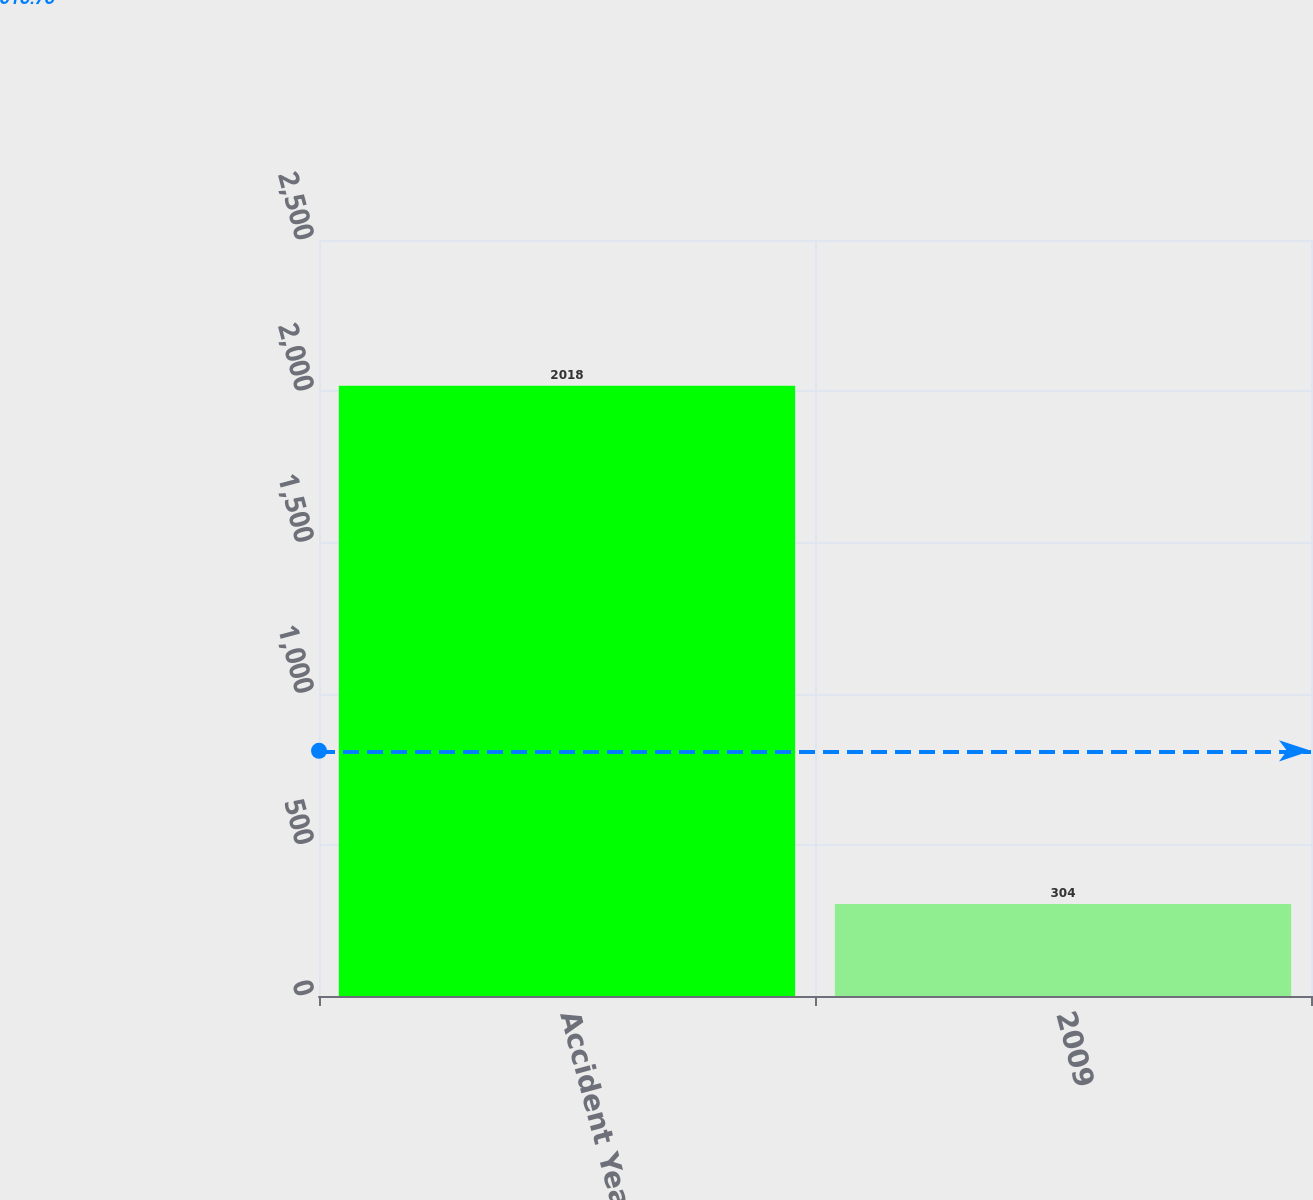<chart> <loc_0><loc_0><loc_500><loc_500><bar_chart><fcel>Accident Year<fcel>2009<nl><fcel>2018<fcel>304<nl></chart> 